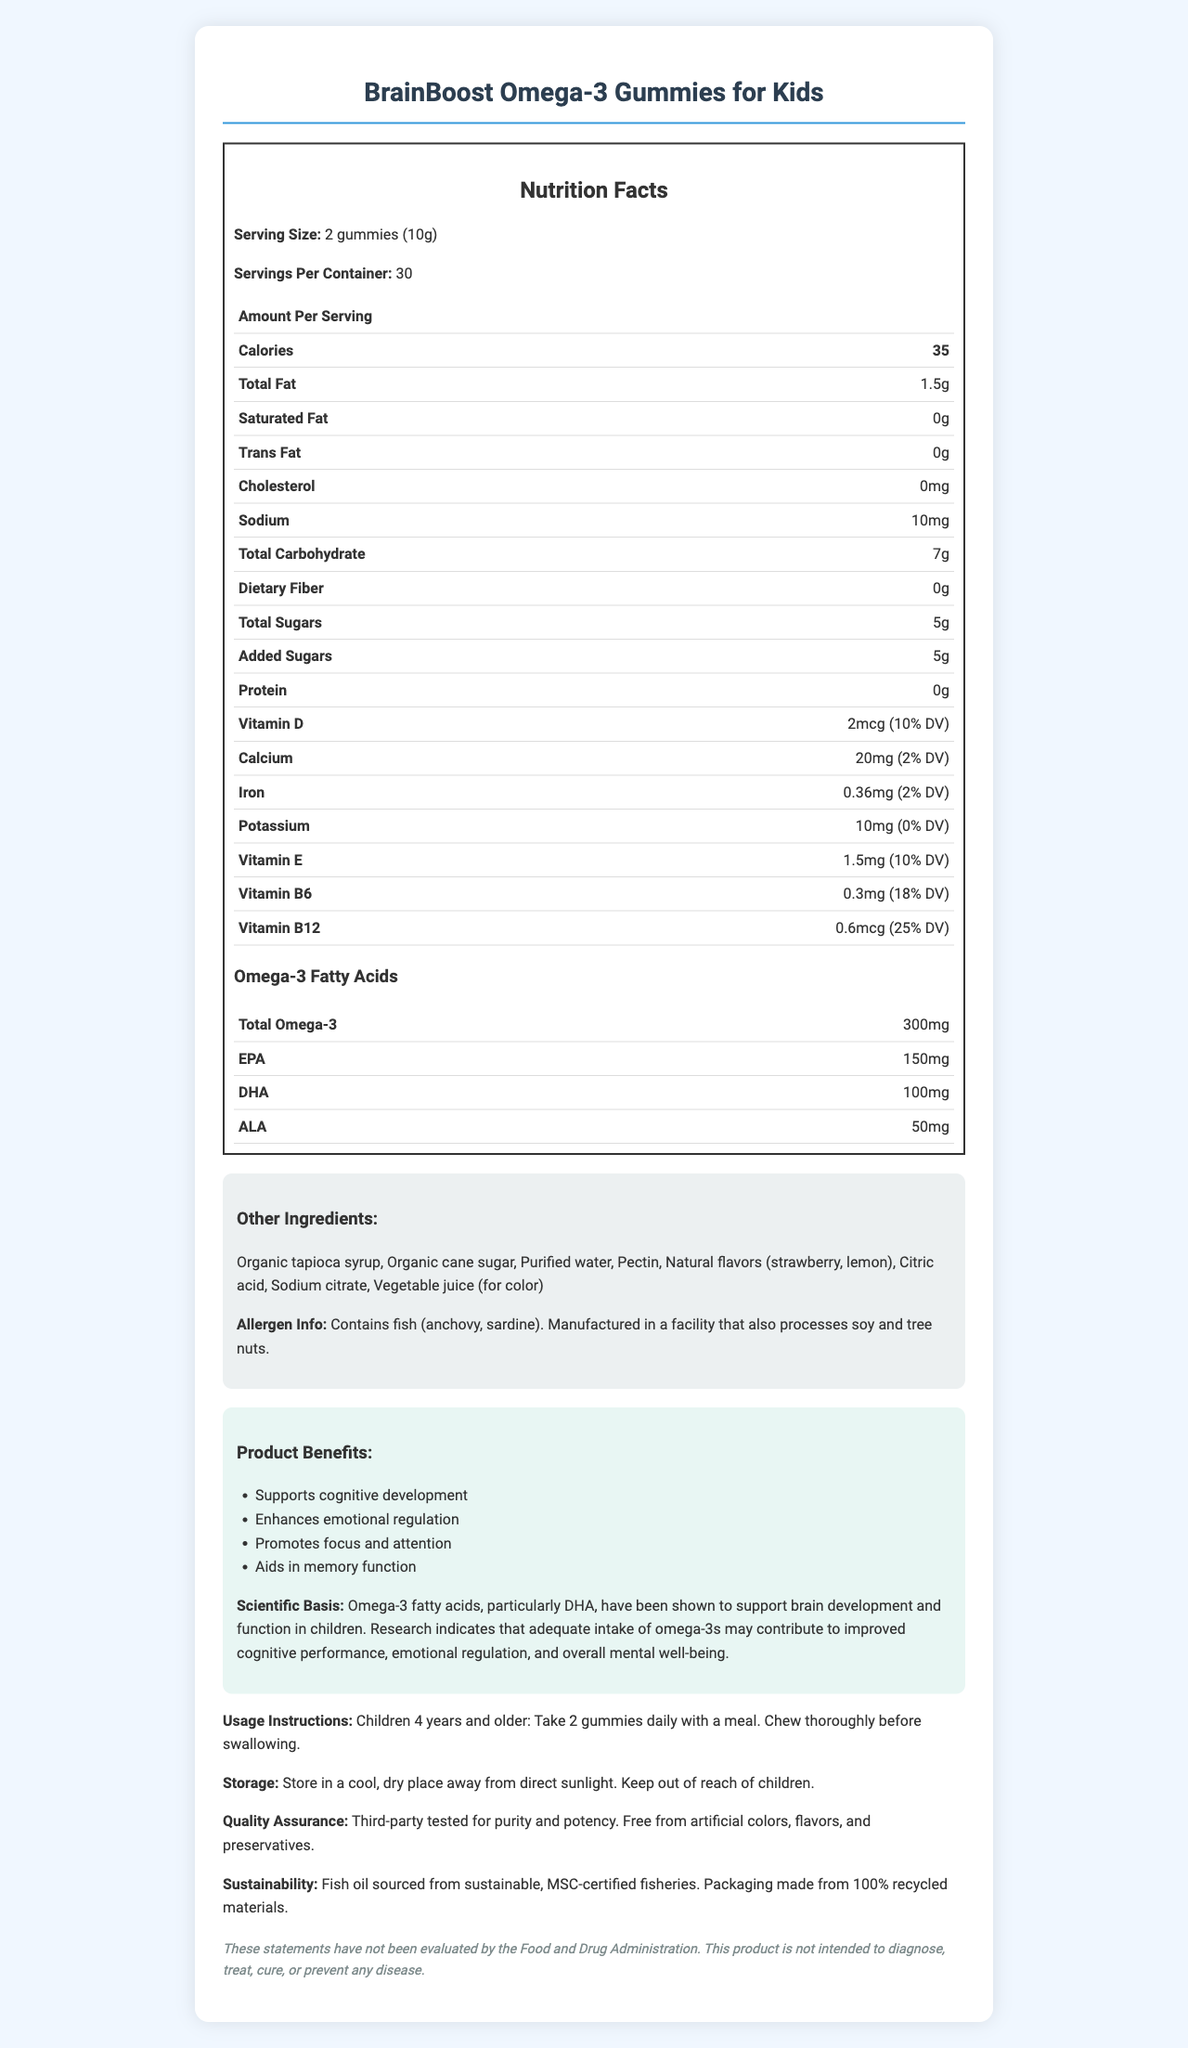how many omega-3 fatty acids are in each serving? According to the table in the "Omega-3 Fatty Acids" section, each serving contains a total of 300mg of omega-3 fatty acids.
Answer: 300mg what is the serving size for the BrainBoost Omega-3 Gummies? The serving size is clearly listed at the top of the Nutrition Facts section as "2 gummies (10g)".
Answer: 2 gummies (10g) how many calories are in each serving? The calorie count is explicitly listed under the "Nutrition Facts" section as 35 calories per serving.
Answer: 35 which fish are the omega-3 fatty acids derived from? The allergen information states that the product contains fish (anchovy, sardine).
Answer: anchovy and sardine what percentage of the daily value of vitamin B12 do the gummies provide? The Nutrition Facts section shows that each serving provides 0.6mcg of vitamin B12, which is 25% of the daily value.
Answer: 25% how much added sugar is in each serving? A. 7g B. 10g C. 5g D. 0g The Nutrition Facts section indicates there are 5g of added sugars per serving.
Answer: C which of the following is not a benefit of the BrainBoost Omega-3 Gummies? A. Enhances emotional regulation B. Strengthens bones C. Aids in memory function The listed benefits do not include strengthening bones; they focus on cognitive development and emotional regulation.
Answer: B are the BrainBoost Gummies suitable for children with peanut allergies? The allergen info only mentions fish, soy, and tree nuts but does not specify about peanuts, so it's not conclusive.
Answer: Cannot be determined does the product include artificial colors? The Quality Assurance section states that the product is free from artificial colors, flavors, and preservatives.
Answer: No summarize the main idea of the document. The document outlines the product's intended benefits, nutritional content, usage instructions, allergen information, and quality assurance details.
Answer: BrainBoost Omega-3 Gummies for Kids are designed to support cognitive and emotional development in children, featuring key nutrients and omega-3 fatty acids. The product is free from artificial additives and is sustainably sourced. Instructions and nutritional information are detailed for consumer clarity. what are the main ingredients used for sweetening the gummies? The "Other Ingredients" section lists organic tapioca syrup and organic cane sugar as sweetening agents.
Answer: Organic tapioca syrup, Organic cane sugar 